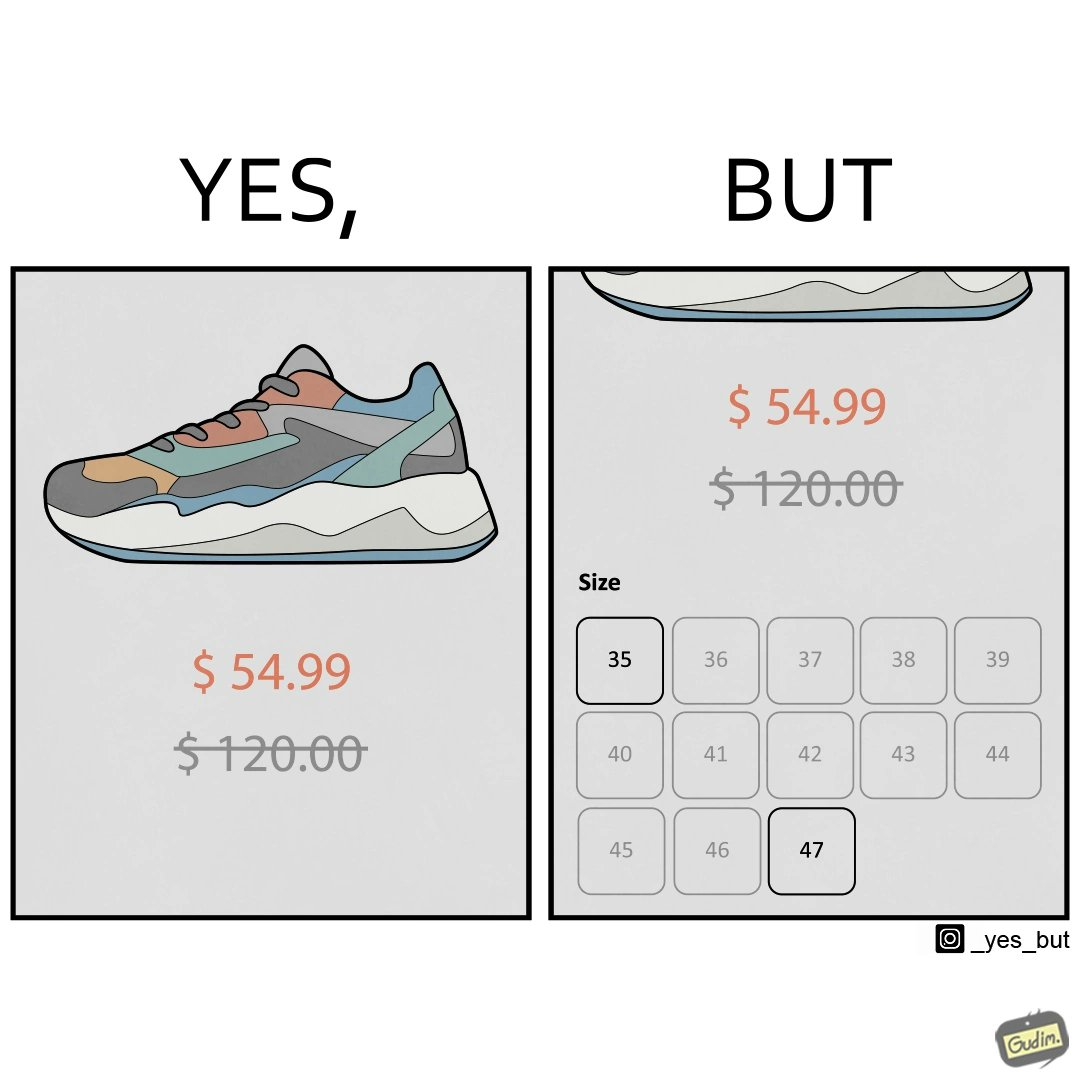Describe what you see in the left and right parts of this image. In the left part of the image: The image shows a shoe. The old of price of the shoe which was $120 has been crossed of and the new price is just $54.99. In the right part of the image: The image shows a part of the shoe, its new price and old, crossed off price and available sizes. The old price was $120 and the new price is $54.99. There are only 2 available sizes which are 35 and 47. These two sizes are the smallest and the largest respectively of all the available sizes. 